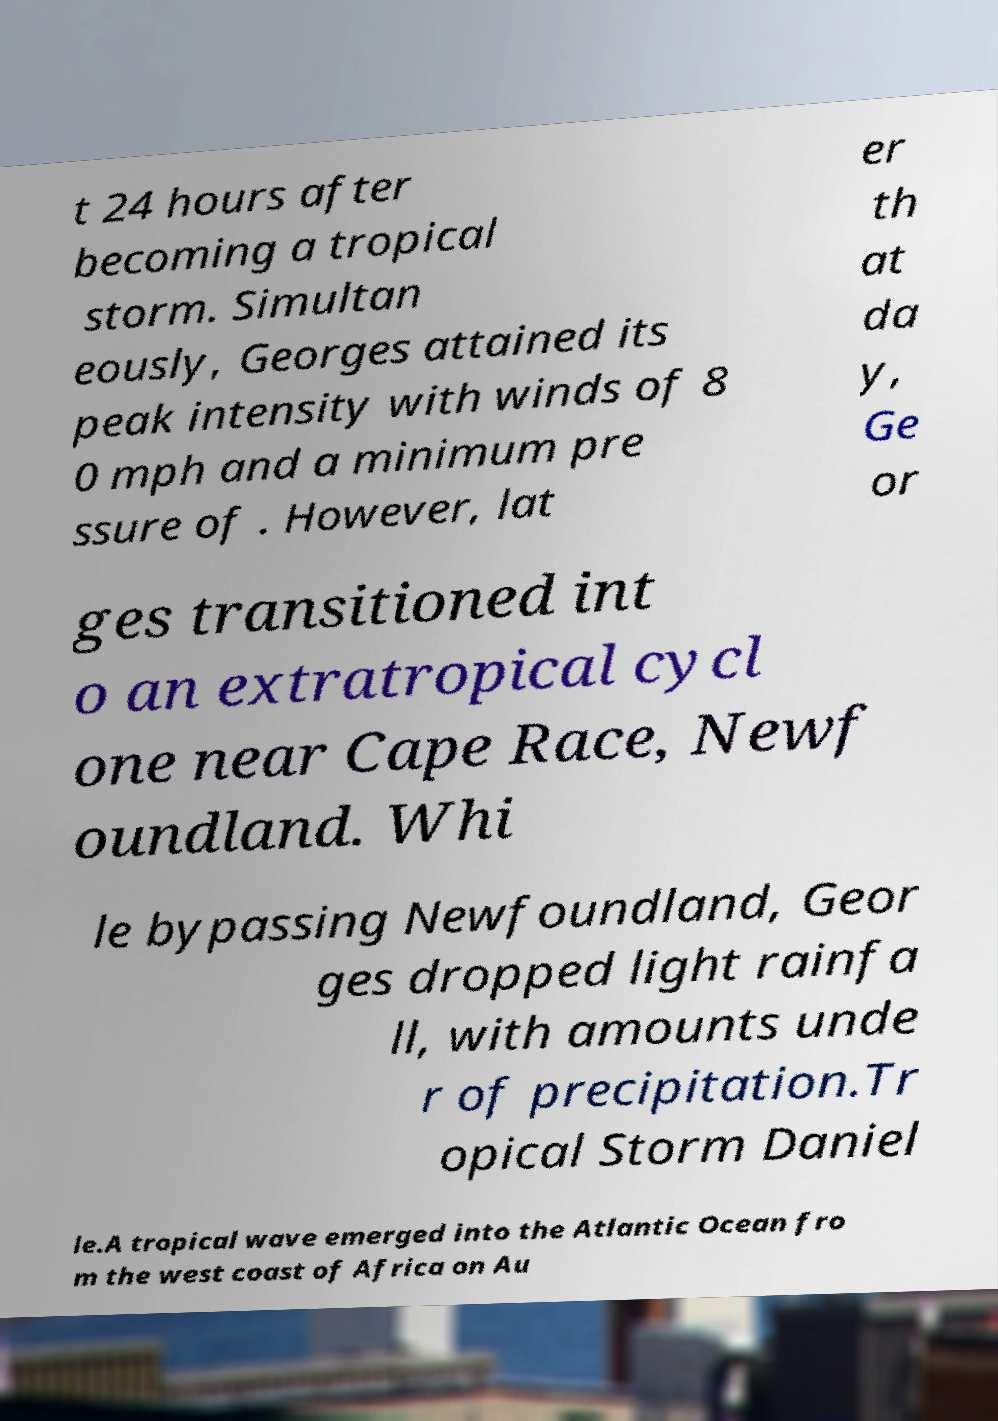There's text embedded in this image that I need extracted. Can you transcribe it verbatim? t 24 hours after becoming a tropical storm. Simultan eously, Georges attained its peak intensity with winds of 8 0 mph and a minimum pre ssure of . However, lat er th at da y, Ge or ges transitioned int o an extratropical cycl one near Cape Race, Newf oundland. Whi le bypassing Newfoundland, Geor ges dropped light rainfa ll, with amounts unde r of precipitation.Tr opical Storm Daniel le.A tropical wave emerged into the Atlantic Ocean fro m the west coast of Africa on Au 